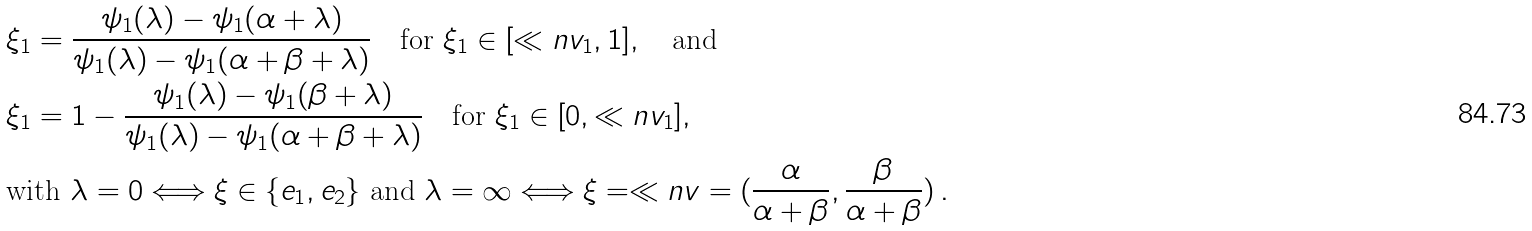Convert formula to latex. <formula><loc_0><loc_0><loc_500><loc_500>& \xi _ { 1 } = \frac { \psi _ { 1 } ( \lambda ) - \psi _ { 1 } ( \alpha + \lambda ) } { \psi _ { 1 } ( \lambda ) - \psi _ { 1 } ( \alpha + \beta + \lambda ) } \quad \text {for } \xi _ { 1 } \in [ \ll n v _ { 1 } , 1 ] , \quad \text {and} \\ & \xi _ { 1 } = 1 - \frac { \psi _ { 1 } ( \lambda ) - \psi _ { 1 } ( \beta + \lambda ) } { \psi _ { 1 } ( \lambda ) - \psi _ { 1 } ( \alpha + \beta + \lambda ) } \quad \text {for } \xi _ { 1 } \in [ 0 , \ll n v _ { 1 } ] , \\ & \text {with } \lambda = 0 \Longleftrightarrow \xi \in \{ e _ { 1 } , e _ { 2 } \} \text { and } \lambda = \infty \Longleftrightarrow \xi = \ll n v = ( \frac { \alpha } { \alpha + \beta } , \frac { \beta } { \alpha + \beta } ) \, .</formula> 